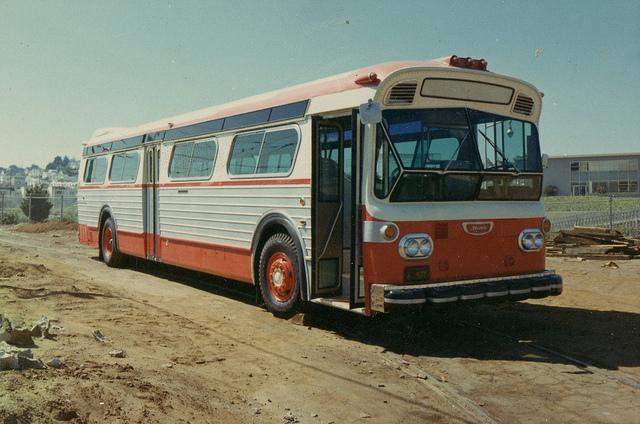Is anybody driving the bus?
Be succinct. No. What type of bus is this?
Be succinct. Passenger. What color is the bus?
Concise answer only. Red and white. Is there sunlight?
Concise answer only. Yes. Where is the bus?
Give a very brief answer. At prison. Is the bus running?
Quick response, please. No. What color is this bus?
Give a very brief answer. White and red. How many terminals are shown in the picture?
Quick response, please. 0. Is this a public bus or charter bus?
Be succinct. Public. 